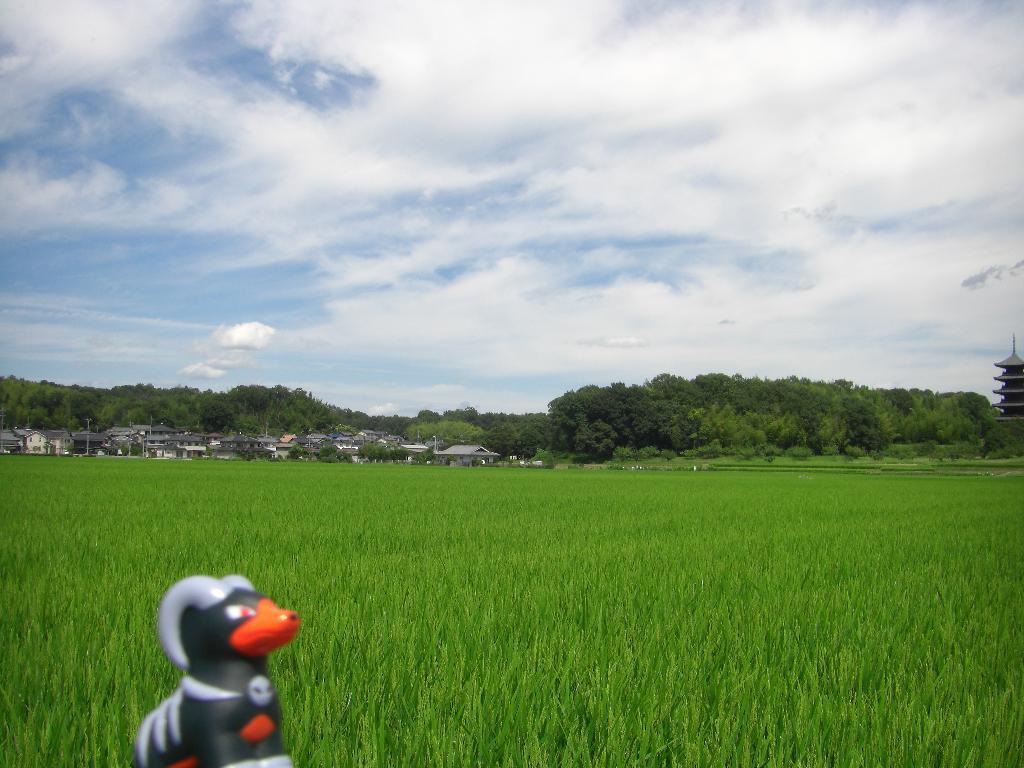Please provide a concise description of this image. On the left at the bottom there is a toy. In the background there is a field,trees,houses,buildings and clouds in the sky. 